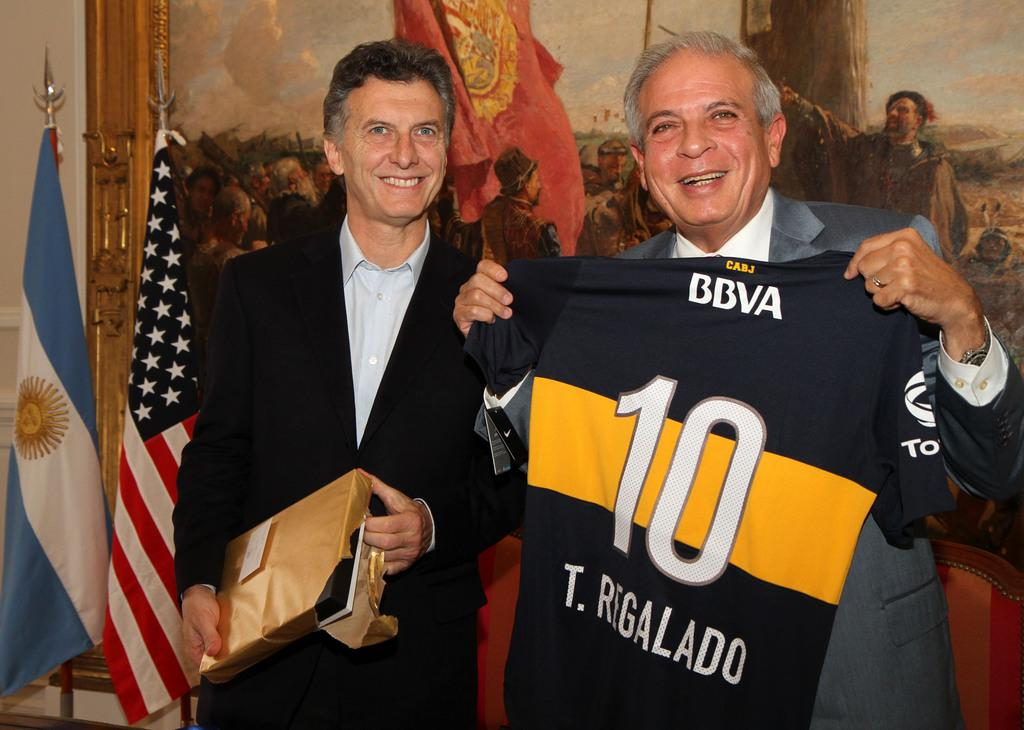<image>
Describe the image concisely. Man holding a black and yellow jersey which says BBVA on it. 